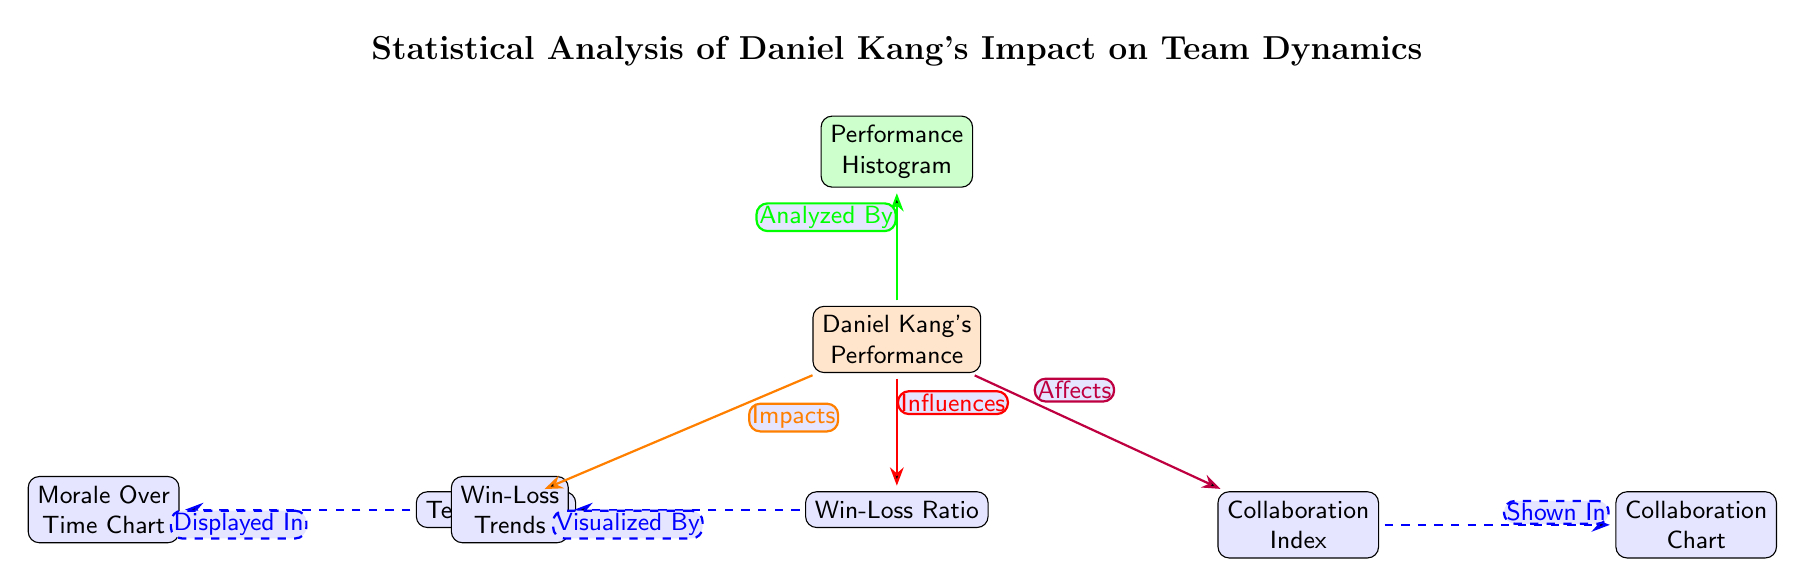What is the color of Daniel Kang's performance node? The node representing Daniel Kang's performance is colored orange with a shade classification of 20.
Answer: orange!20 How many nodes are present in the diagram? The diagram consists of a total of six nodes including Daniel Kang's performance and its related metrics.
Answer: six Which metric is affected by Daniel Kang's performance and is associated with team morale? The arrow indicates that Team Morale is impacted by Daniel Kang's performance as denoted by the connection between these two nodes.
Answer: Team Morale What is displayed in the chart that is linked to Team Morale? The connecting edge between Team Morale and the chart node specifies that the Morale Over Time Chart displays the morale metric over a timeline.
Answer: Morale Over Time Chart What does the thick red edge represent in the diagram? The thick red edge connecting Daniel Kang's performance with the Win-Loss ratio signifies that Daniel Kang influences the Win-Loss Ratio directly.
Answer: Influences How many categories are used to analyze Daniel Kang's impact? Analyzing Daniel Kang's impact entails using four categories that depict the relationships between his performance and team dynamics.
Answer: four What type of chart visualizes the win-loss trends? The diagram shows that win-loss trends are visualized through a specific chart linked to the Win-Loss Ratio node in the diagram.
Answer: Win-Loss Trends Which two metrics are shown side by side in relation to Daniel Kang's performance? The diagram places Team Morale and Win-Loss Ratio directly beneath the performance node, signifying their direct relationship with it.
Answer: Team Morale and Win-Loss Ratio What is the main subject of the title above the histogram? The title above the performance histogram rightfully identifies the core focus of the analysis regarding Daniel Kang's influence.
Answer: Statistical Analysis of Daniel Kang's Impact on Team Dynamics 